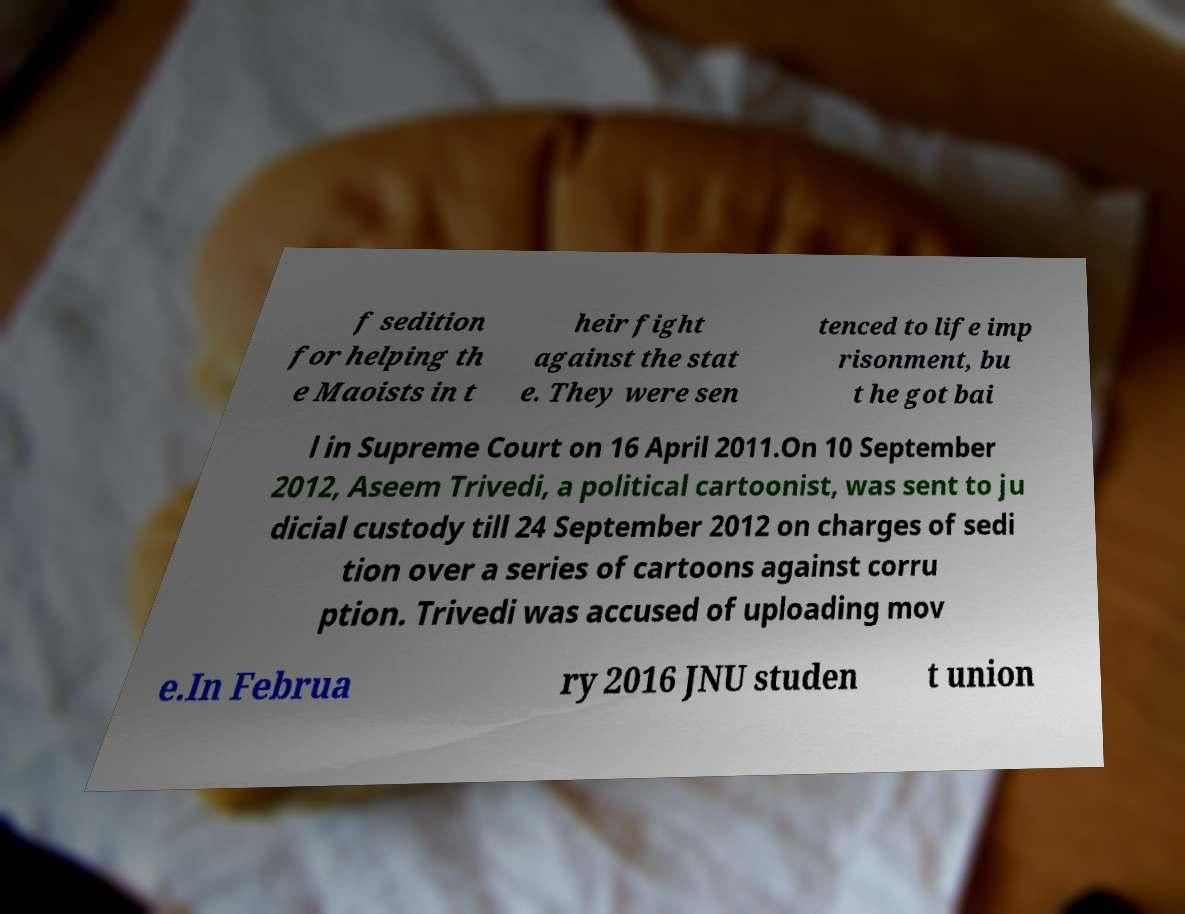I need the written content from this picture converted into text. Can you do that? f sedition for helping th e Maoists in t heir fight against the stat e. They were sen tenced to life imp risonment, bu t he got bai l in Supreme Court on 16 April 2011.On 10 September 2012, Aseem Trivedi, a political cartoonist, was sent to ju dicial custody till 24 September 2012 on charges of sedi tion over a series of cartoons against corru ption. Trivedi was accused of uploading mov e.In Februa ry 2016 JNU studen t union 